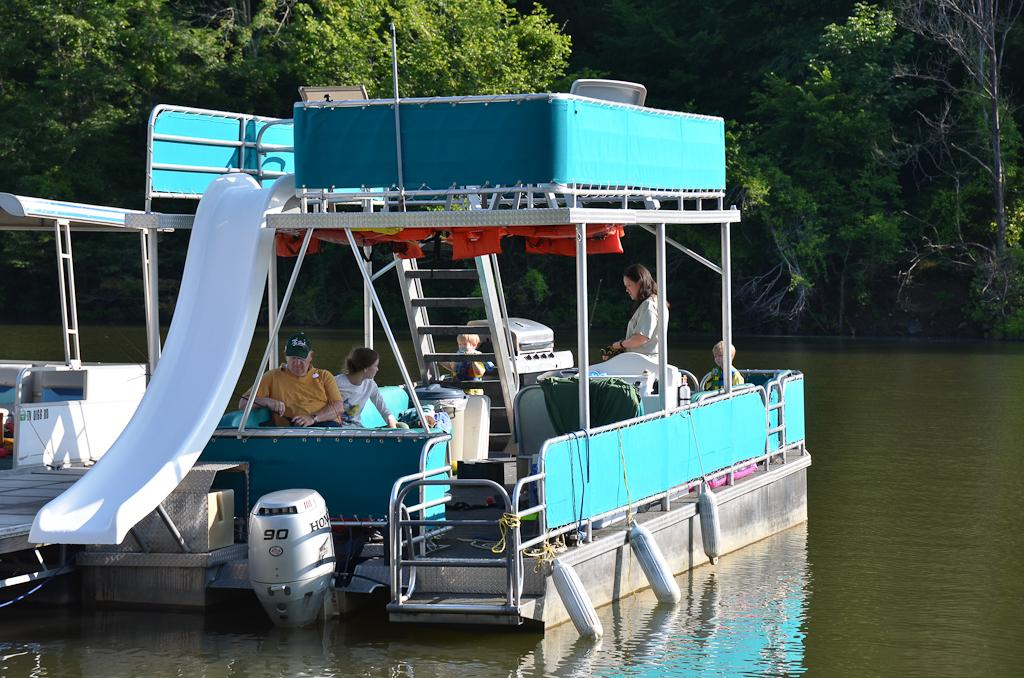What is in the water in the image? There is a boat in the water in the image. How many people are in the boat? There are four persons sitting in the boat. What powers the boat? There is a motor at the bottom of the boat. What can be seen in the background of the image? There are trees in the background of the image. What type of development is taking place during the recess in the image? There is no reference to a recess or development in the image; it features a boat with people and trees in the background. 